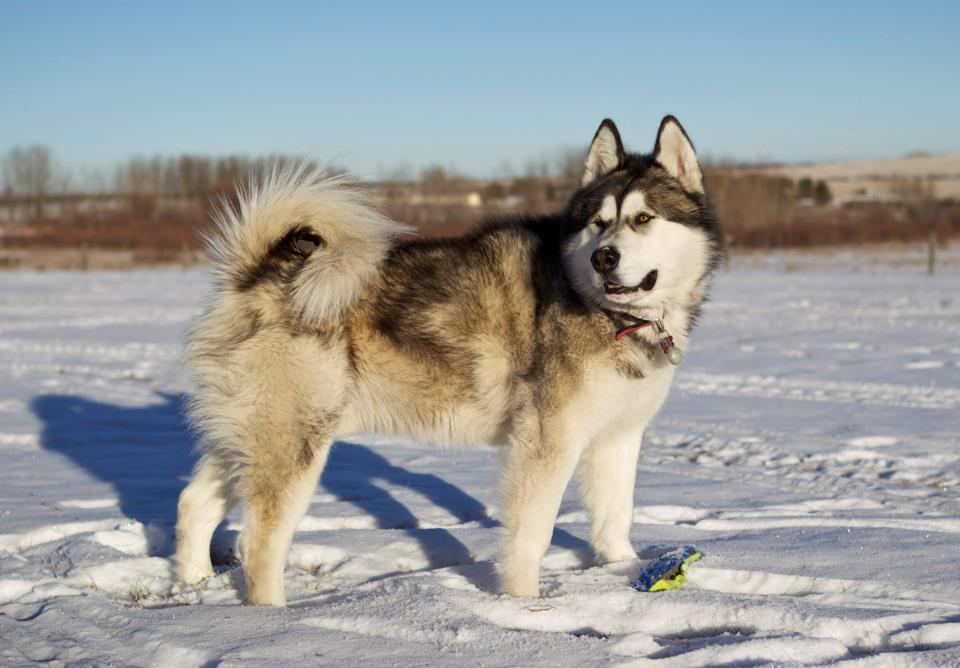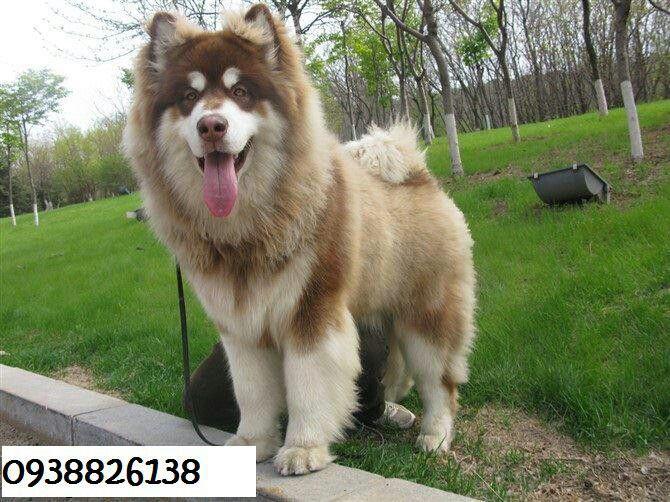The first image is the image on the left, the second image is the image on the right. Considering the images on both sides, is "There are only two dogs." valid? Answer yes or no. Yes. The first image is the image on the left, the second image is the image on the right. Analyze the images presented: Is the assertion "No image contains more than one dog, all dogs are husky-type, and the image on the left shows a dog standing on all fours." valid? Answer yes or no. Yes. 